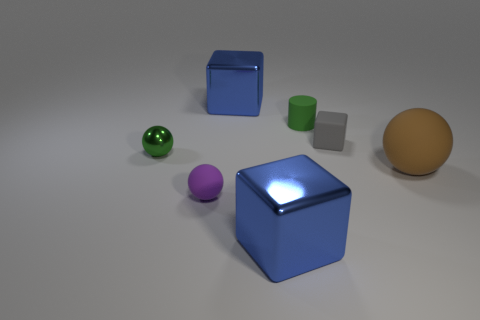Add 1 small gray metallic spheres. How many objects exist? 8 Subtract all cylinders. How many objects are left? 6 Subtract 0 green blocks. How many objects are left? 7 Subtract all big shiny objects. Subtract all purple rubber balls. How many objects are left? 4 Add 2 green matte things. How many green matte things are left? 3 Add 3 tiny green matte spheres. How many tiny green matte spheres exist? 3 